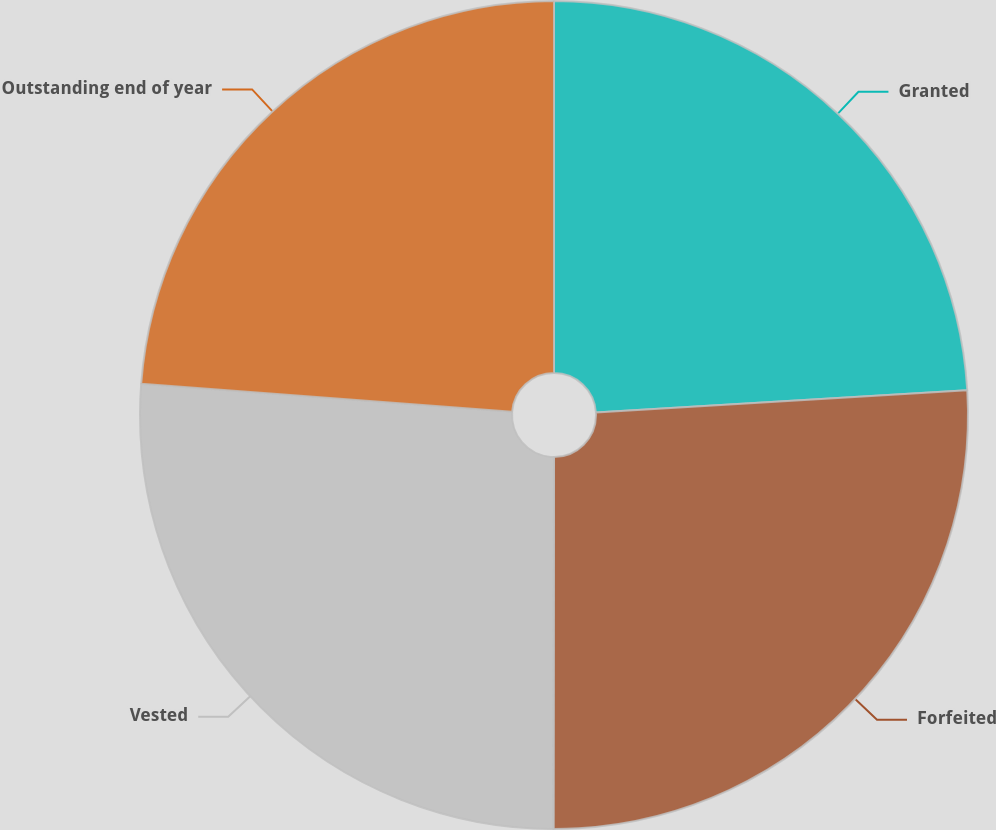Convert chart. <chart><loc_0><loc_0><loc_500><loc_500><pie_chart><fcel>Granted<fcel>Forfeited<fcel>Vested<fcel>Outstanding end of year<nl><fcel>24.05%<fcel>25.97%<fcel>26.18%<fcel>23.8%<nl></chart> 